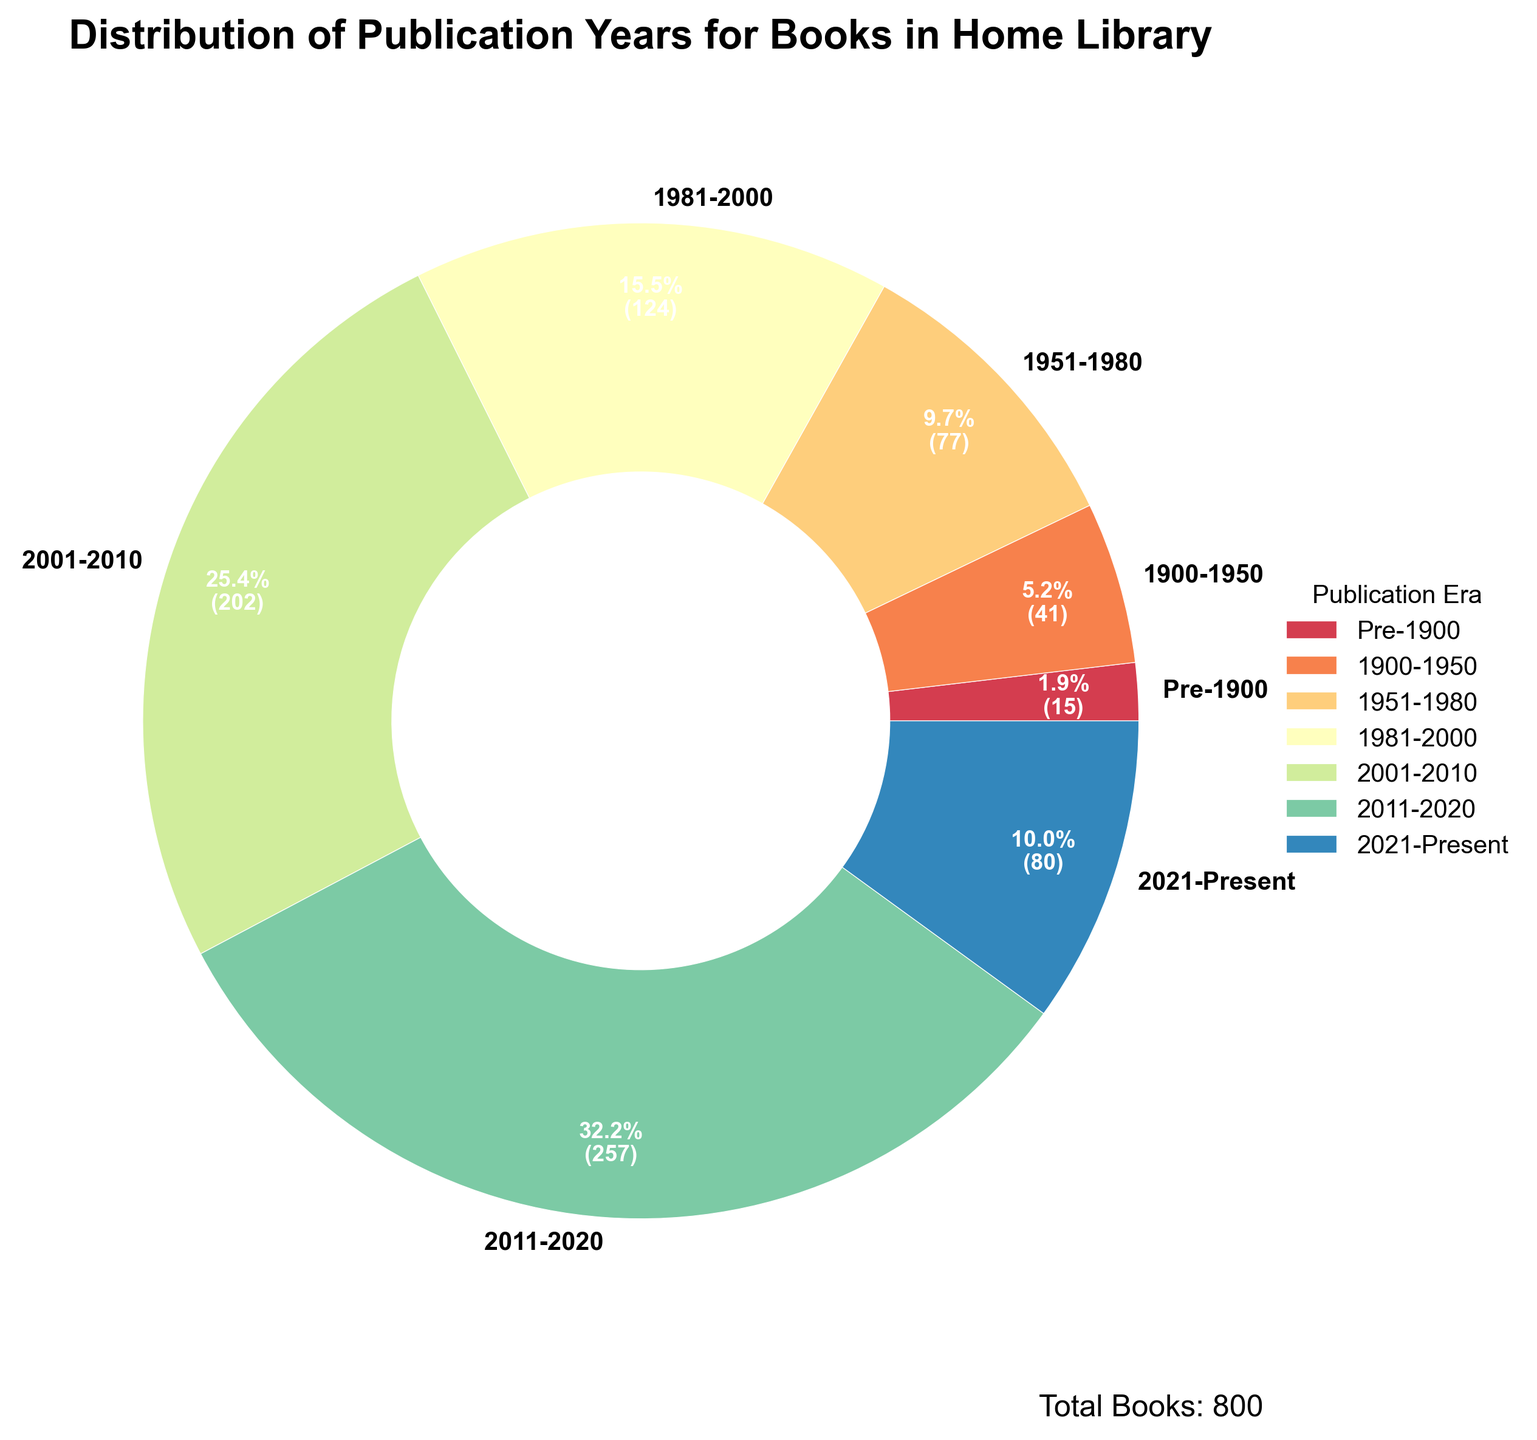Which publication era had the highest number of books? The largest wedge in the pie chart represents the era with the highest number of books. The 2011-2020 era has the largest wedge.
Answer: 2011-2020 What percentage of books were published between 2001 and 2020? Add the percentages for the 2001-2010 and 2011-2020 eras as displayed on the pie chart. The combined percentage is shown as 31.8% + 40.5%.
Answer: 72.3% How many books were published in the 21st century (2001-Present)? Sum the numbers of books for the 2001-2010, 2011-2020, and 2021-Present eras. The sum is 203 + 258 + 80.
Answer: 541 Compare the number of books published from 1951-1980 to those published from 1981-2000. The wedges for 1951-1980 and 1981-2000 are 78 and 124 books respectively. 124 is greater than 78.
Answer: 1981-2000 > 1951-1980 Which era has the smallest number of books and what is the count? The smallest wedge corresponds to the era with the fewest books. The Pre-1900 era has 15 books, the smallest number.
Answer: Pre-1900, 15 If the total number of books is 800, what is the percentage of books published before 1950? Combine the number of books for the Pre-1900 and 1900-1950 eras, then divide by the total and multiply by 100. (15+42)/800 * 100 = 7.125%.
Answer: 7.1% How many more books were published between 2011-2020 compared to Pre-1900? Subtract the number of books in the Pre-1900 era from those in the 2011-2020 era. 258 - 15 = 243.
Answer: 243 What fraction of the library's books were published in the 1981-2000 era? Divide the number of books published in the 1981-2000 era by the total number of books. 124/800 = 0.155.
Answer: 0.155 Is the number of books published between 1951-2000 greater or less than the number published after 2000? Sum the books from 1951-1980 and 1981-2000, then compare with the sum of books from 2001-2010, 2011-2020, and 2021-Present (78+124 vs 203+258+80). The values are 202 and 541 respectively.
Answer: Less 